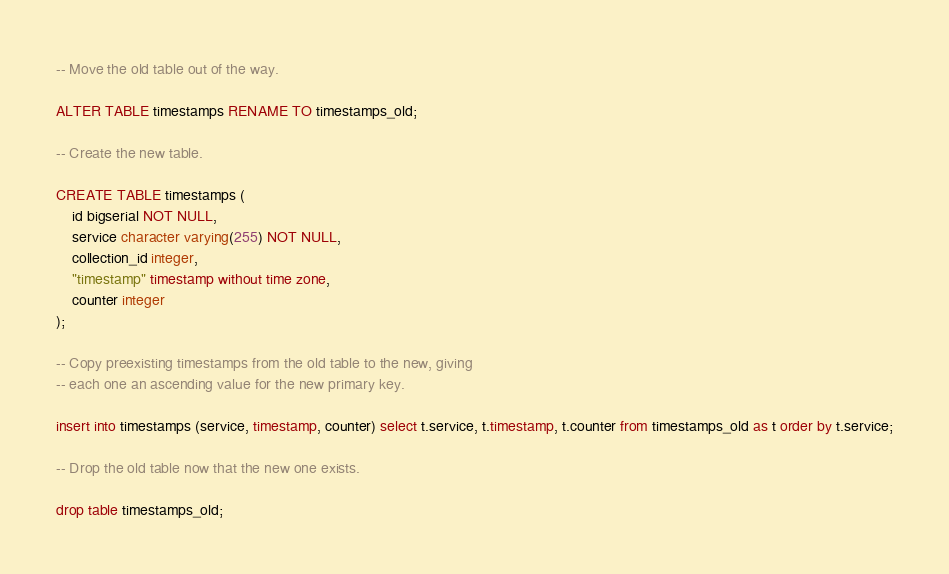<code> <loc_0><loc_0><loc_500><loc_500><_SQL_>-- Move the old table out of the way.

ALTER TABLE timestamps RENAME TO timestamps_old;

-- Create the new table.

CREATE TABLE timestamps (
    id bigserial NOT NULL,
    service character varying(255) NOT NULL,
    collection_id integer,
    "timestamp" timestamp without time zone,
    counter integer
);

-- Copy preexisting timestamps from the old table to the new, giving
-- each one an ascending value for the new primary key.

insert into timestamps (service, timestamp, counter) select t.service, t.timestamp, t.counter from timestamps_old as t order by t.service;

-- Drop the old table now that the new one exists.

drop table timestamps_old;
</code> 